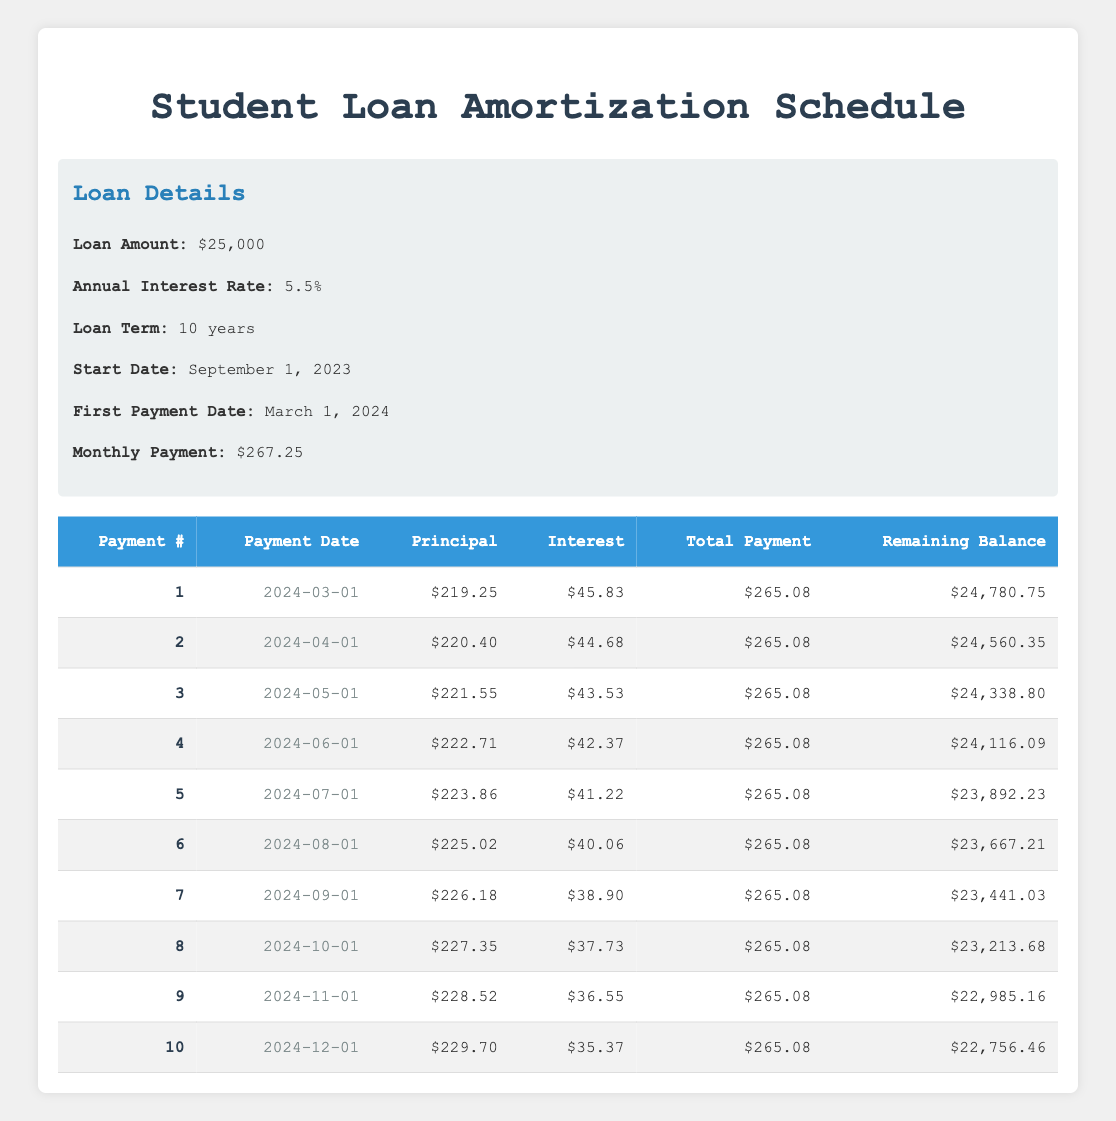What is the total monthly payment for the loan? The table states that the monthly payment is $267.25.
Answer: 267.25 What is the remaining balance after the first payment? The remaining balance after the first payment is listed as $24,780.75 in the table.
Answer: 24,780.75 How much is the principal payment for the third payment? The principal payment for the third payment is shown as $221.55 in the table.
Answer: 221.55 What is the total amount paid in interest after the first three payments? The interest payments of the first three payments are $45.83, $44.68, and $43.53. Adding these gives: 45.83 + 44.68 + 43.53 = 134.04.
Answer: 134.04 Is the monthly payment consistent for each payment in the table? Yes, all monthly payments listed in the table are the same at $265.08.
Answer: Yes What is the date of the fifth payment, and what is the remaining balance after this payment? The fifth payment date is July 1, 2024. The remaining balance after this payment is $23,892.23.
Answer: July 1, 2024; 23,892.23 By what amount does the remaining balance decrease from the first payment to the second payment? The remaining balance after the first payment is $24,780.75 and after the second payment is $24,560.35. The difference is 24,780.75 - 24,560.35 = 220.40.
Answer: 220.40 What is the average interest payment over the first ten payments? The interest payments for the first ten payments are listed, summing them gives: (45.83 + 44.68 + 43.53 + 42.37 + 41.22 + 40.06 + 38.90 + 37.73 + 36.55 + 35.37) = 454.20. Dividing by 10 gives the average: 454.20 / 10 = 45.42.
Answer: 45.42 How many payments will it take to fully pay off the loan if the schedule remains consistent? The loan term is 10 years, equating to 120 monthly payments. Therefore, it will take 120 payments to fully pay off the loan.
Answer: 120 